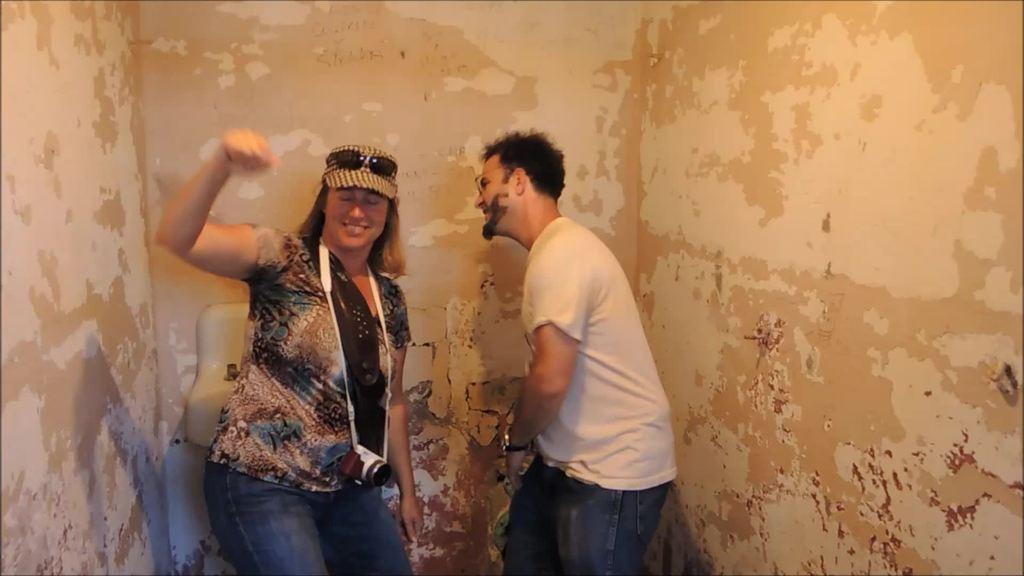Please provide a concise description of this image. In this image I can see two persons standing and I can also see the camera. In the background the wall is in cream color. 